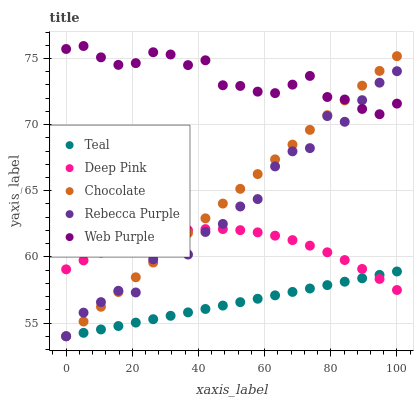Does Teal have the minimum area under the curve?
Answer yes or no. Yes. Does Web Purple have the maximum area under the curve?
Answer yes or no. Yes. Does Deep Pink have the minimum area under the curve?
Answer yes or no. No. Does Deep Pink have the maximum area under the curve?
Answer yes or no. No. Is Teal the smoothest?
Answer yes or no. Yes. Is Rebecca Purple the roughest?
Answer yes or no. Yes. Is Deep Pink the smoothest?
Answer yes or no. No. Is Deep Pink the roughest?
Answer yes or no. No. Does Rebecca Purple have the lowest value?
Answer yes or no. Yes. Does Deep Pink have the lowest value?
Answer yes or no. No. Does Web Purple have the highest value?
Answer yes or no. Yes. Does Deep Pink have the highest value?
Answer yes or no. No. Is Deep Pink less than Web Purple?
Answer yes or no. Yes. Is Web Purple greater than Teal?
Answer yes or no. Yes. Does Deep Pink intersect Chocolate?
Answer yes or no. Yes. Is Deep Pink less than Chocolate?
Answer yes or no. No. Is Deep Pink greater than Chocolate?
Answer yes or no. No. Does Deep Pink intersect Web Purple?
Answer yes or no. No. 